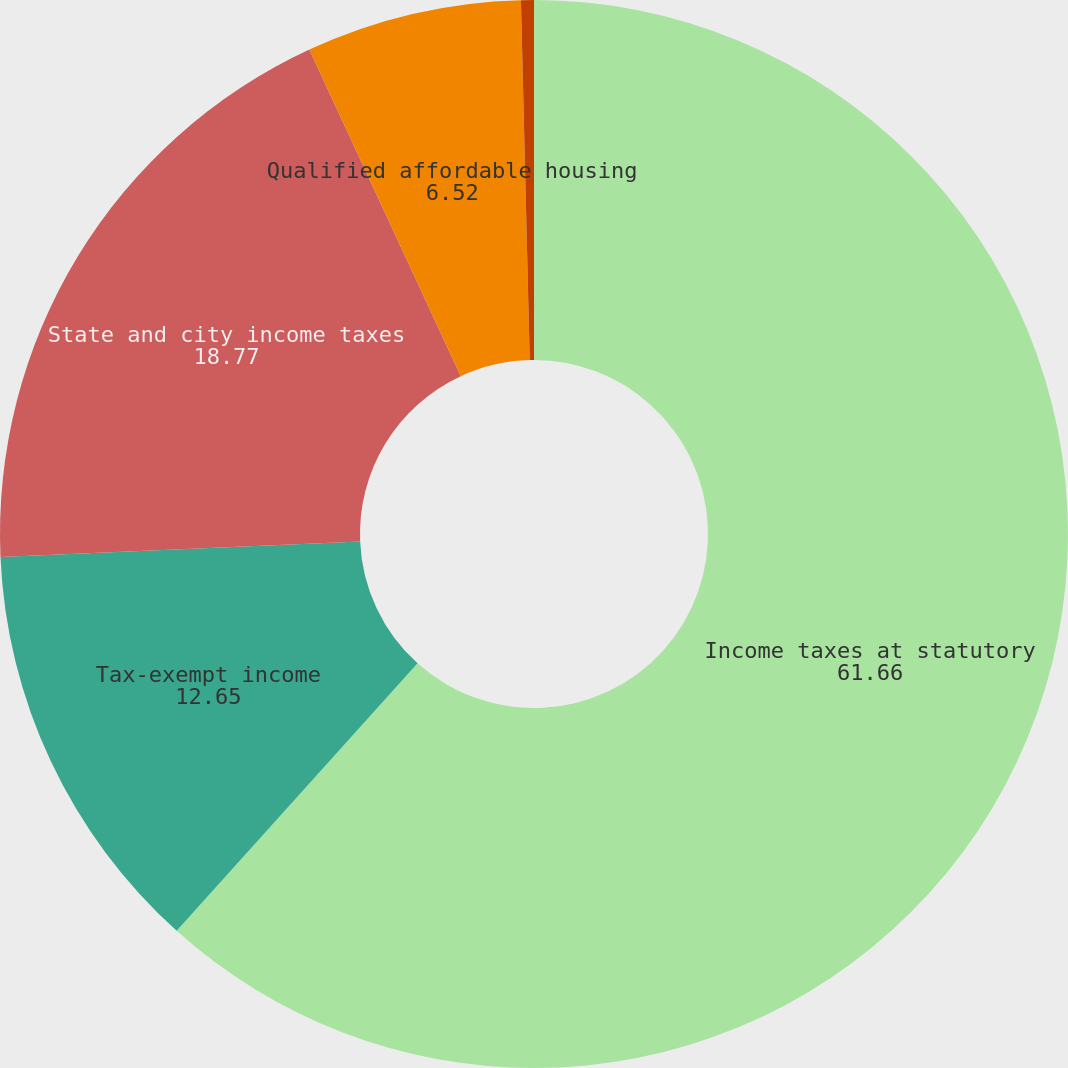Convert chart to OTSL. <chart><loc_0><loc_0><loc_500><loc_500><pie_chart><fcel>Income taxes at statutory<fcel>Tax-exempt income<fcel>State and city income taxes<fcel>Qualified affordable housing<fcel>Other<nl><fcel>61.66%<fcel>12.65%<fcel>18.77%<fcel>6.52%<fcel>0.39%<nl></chart> 